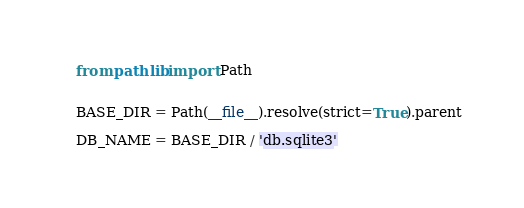<code> <loc_0><loc_0><loc_500><loc_500><_Python_>from pathlib import Path


BASE_DIR = Path(__file__).resolve(strict=True).parent

DB_NAME = BASE_DIR / 'db.sqlite3'
</code> 